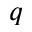<formula> <loc_0><loc_0><loc_500><loc_500>q</formula> 